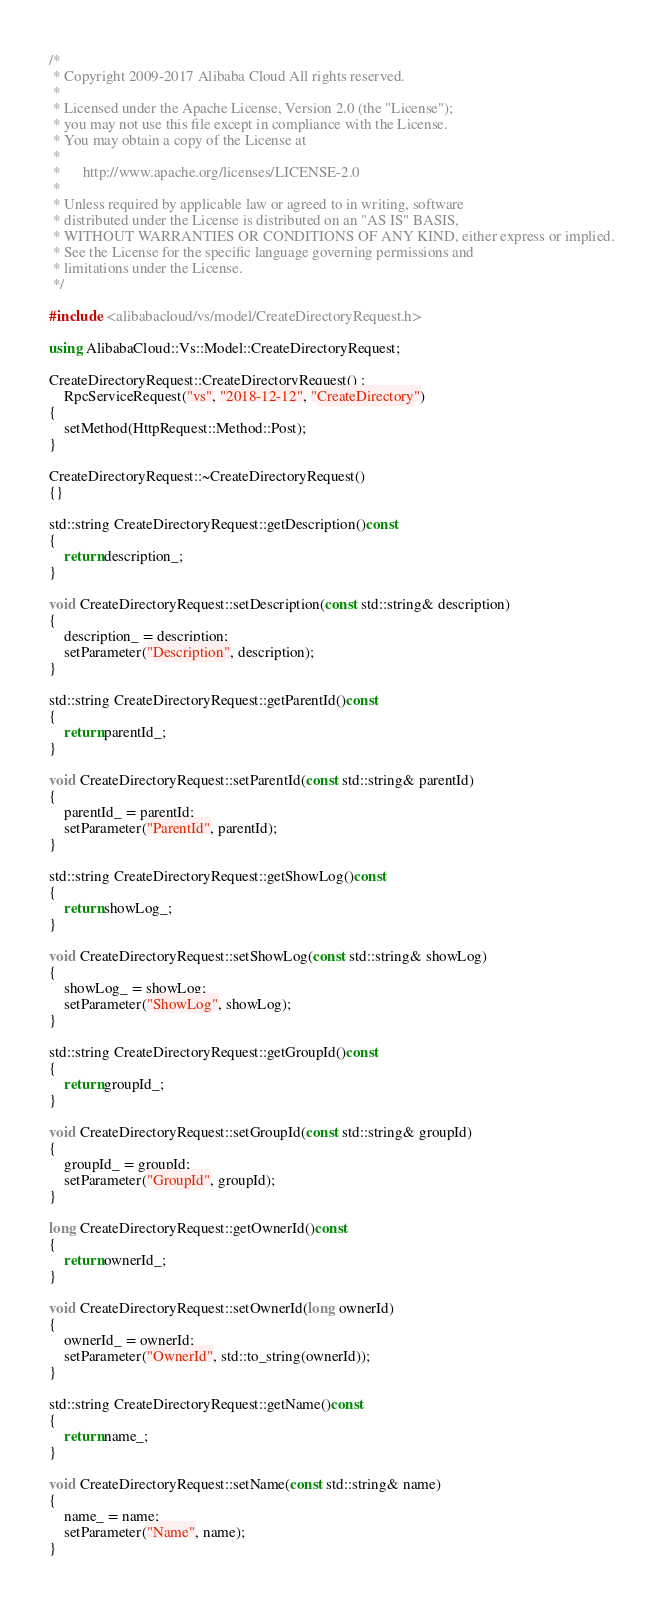Convert code to text. <code><loc_0><loc_0><loc_500><loc_500><_C++_>/*
 * Copyright 2009-2017 Alibaba Cloud All rights reserved.
 * 
 * Licensed under the Apache License, Version 2.0 (the "License");
 * you may not use this file except in compliance with the License.
 * You may obtain a copy of the License at
 * 
 *      http://www.apache.org/licenses/LICENSE-2.0
 * 
 * Unless required by applicable law or agreed to in writing, software
 * distributed under the License is distributed on an "AS IS" BASIS,
 * WITHOUT WARRANTIES OR CONDITIONS OF ANY KIND, either express or implied.
 * See the License for the specific language governing permissions and
 * limitations under the License.
 */

#include <alibabacloud/vs/model/CreateDirectoryRequest.h>

using AlibabaCloud::Vs::Model::CreateDirectoryRequest;

CreateDirectoryRequest::CreateDirectoryRequest() :
	RpcServiceRequest("vs", "2018-12-12", "CreateDirectory")
{
	setMethod(HttpRequest::Method::Post);
}

CreateDirectoryRequest::~CreateDirectoryRequest()
{}

std::string CreateDirectoryRequest::getDescription()const
{
	return description_;
}

void CreateDirectoryRequest::setDescription(const std::string& description)
{
	description_ = description;
	setParameter("Description", description);
}

std::string CreateDirectoryRequest::getParentId()const
{
	return parentId_;
}

void CreateDirectoryRequest::setParentId(const std::string& parentId)
{
	parentId_ = parentId;
	setParameter("ParentId", parentId);
}

std::string CreateDirectoryRequest::getShowLog()const
{
	return showLog_;
}

void CreateDirectoryRequest::setShowLog(const std::string& showLog)
{
	showLog_ = showLog;
	setParameter("ShowLog", showLog);
}

std::string CreateDirectoryRequest::getGroupId()const
{
	return groupId_;
}

void CreateDirectoryRequest::setGroupId(const std::string& groupId)
{
	groupId_ = groupId;
	setParameter("GroupId", groupId);
}

long CreateDirectoryRequest::getOwnerId()const
{
	return ownerId_;
}

void CreateDirectoryRequest::setOwnerId(long ownerId)
{
	ownerId_ = ownerId;
	setParameter("OwnerId", std::to_string(ownerId));
}

std::string CreateDirectoryRequest::getName()const
{
	return name_;
}

void CreateDirectoryRequest::setName(const std::string& name)
{
	name_ = name;
	setParameter("Name", name);
}

</code> 